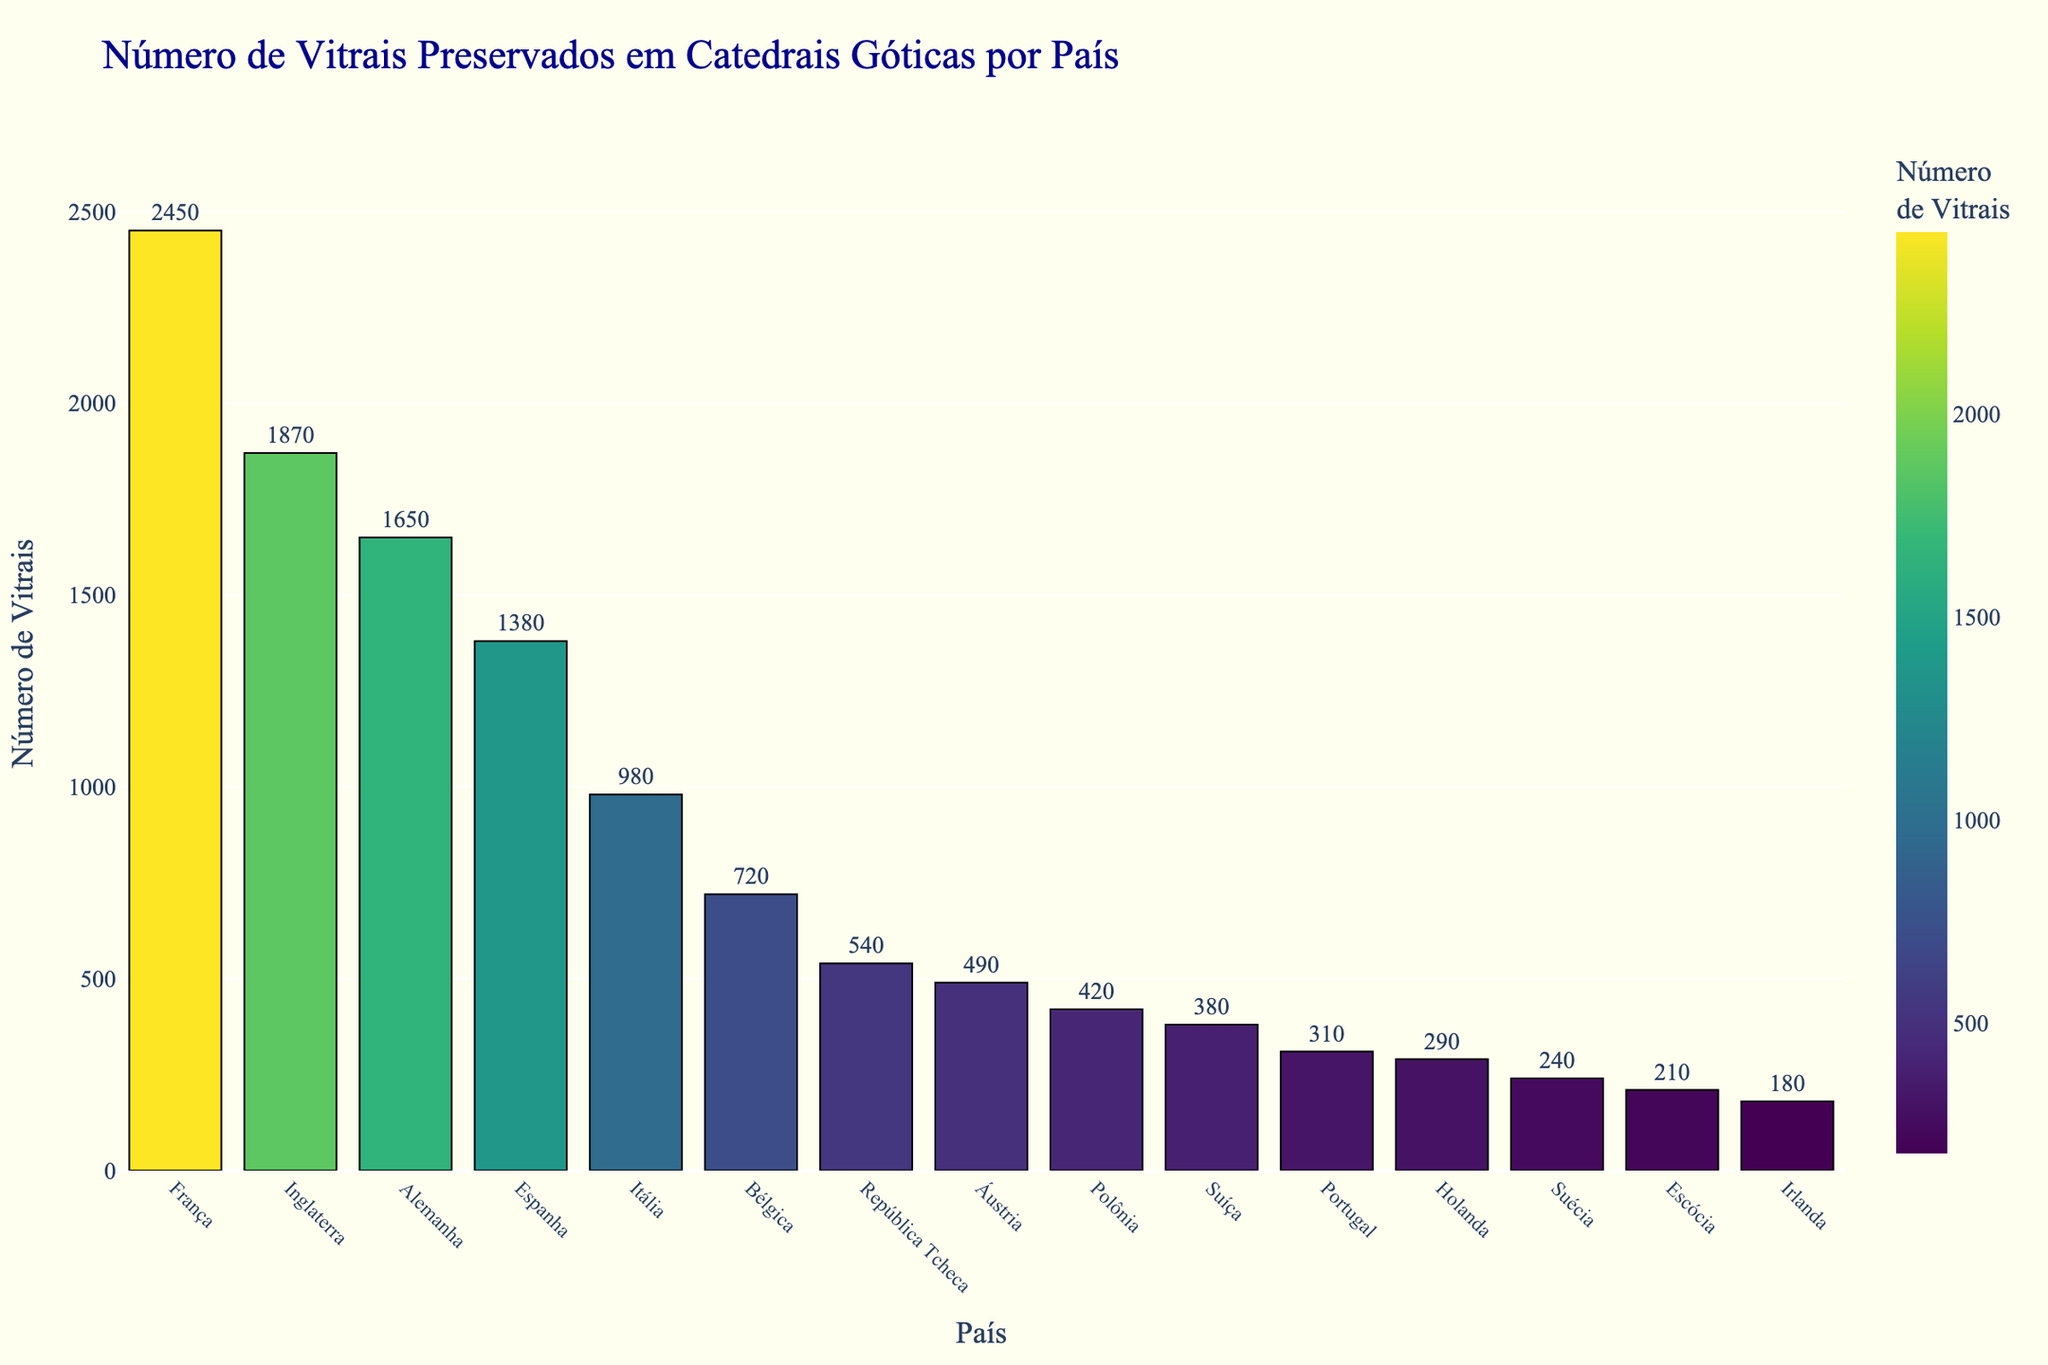What country has the highest number of preserved stained glass windows? By examining the height of the bars, we can see that France has the tallest bar, indicating it has the most preserved stained glass windows.
Answer: France Which countries have fewer preserved stained glass windows than Italy? Comparing the bar heights, we can see that Belgium, the Czech Republic, Austria, Poland, Switzerland, Portugal, the Netherlands, Sweden, Scotland, and Ireland have fewer preserved stained glass windows than Italy.
Answer: Belgium, Czech Republic, Austria, Poland, Switzerland, Portugal, Netherlands, Sweden, Scotland, Ireland How many more preserved stained glass windows does France have compared to Germany? France has 2,450 preserved stained glass windows, and Germany has 1,650. The difference is 2,450 - 1,650 = 800.
Answer: 800 Which country has just slightly more preserved stained glass windows than Belgium? Looking at the bars close to Belgium's in height, the Czech Republic has slightly more with 540 compared to Belgium's 720.
Answer: Czech Republic What is the average number of preserved stained glass windows for the top 5 countries? Summing the numbers for France (2,450), England (1,870), Germany (1,650), Spain (1,380), and Italy (980) gives 8,330. Dividing by 5 gives an average of 8,330 / 5 = 1,666.
Answer: 1,666 How many countries have more than 1,000 preserved stained glass windows? By identifying the heights of the bars above 1,000, we find France, England, Germany, and Spain reaching that threshold. Therefore, there are 4 countries.
Answer: 4 Which two countries have the closest number of preserved stained glass windows? By comparing the numerical values, Austria (490) and Poland (420) are the closest in numbers, with a difference of 70.
Answer: Austria and Poland What is the total number of preserved stained glass windows for all listed countries? Summing the numbers: 2,450 + 1,870 + 1,650 + 1,380 + 980 + 720 + 540 + 490 + 420 + 380 + 310 + 290 + 240 + 210 + 180 = 12,110.
Answer: 12,110 Which country has the lowest number of preserved stained glass windows? Observing the figure, the shortest bar represents Ireland, which has the lowest number of preserved stained glass windows at 180.
Answer: Ireland 